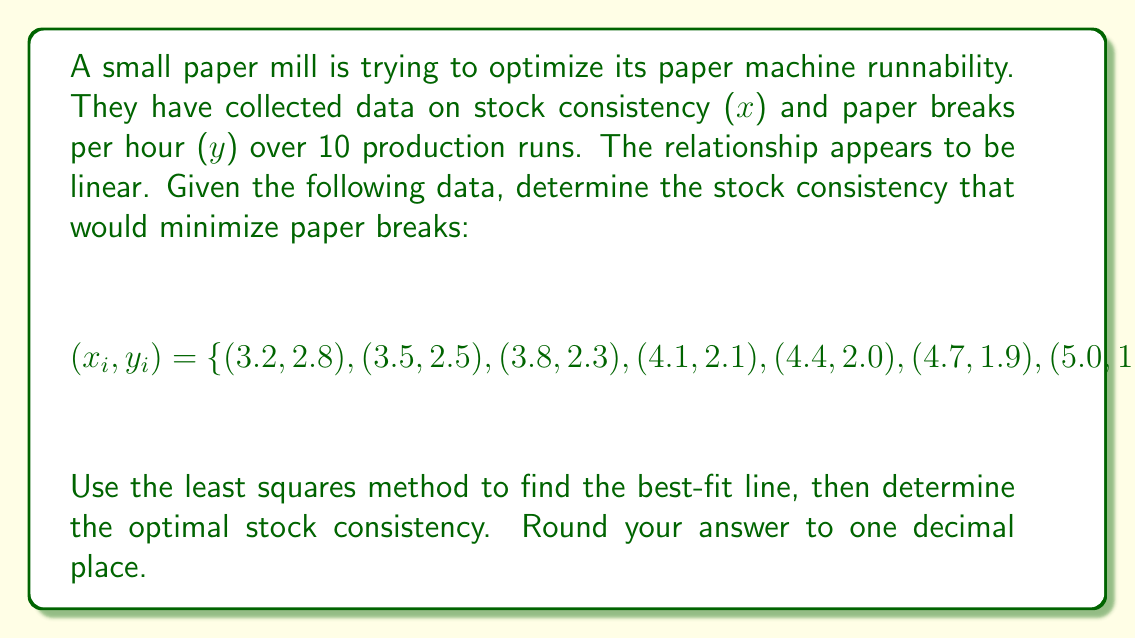Provide a solution to this math problem. To solve this problem, we'll follow these steps:

1) First, we need to find the equation of the best-fit line using the least squares method:
   $y = mx + b$

2) To find m and b, we use these formulas:
   $$m = \frac{n\sum xy - \sum x \sum y}{n\sum x^2 - (\sum x)^2}$$
   $$b = \frac{\sum y \sum x^2 - \sum x \sum xy}{n\sum x^2 - (\sum x)^2}$$

3) Let's calculate the necessary sums:
   $\sum x = 45.5$
   $\sum y = 22.2$
   $\sum xy = 99.31$
   $\sum x^2 = 216.35$
   $n = 10$

4) Now we can calculate m:
   $$m = \frac{10(99.31) - (45.5)(22.2)}{10(216.35) - (45.5)^2} = -0.348$$

5) And b:
   $$b = \frac{22.2(216.35) - 45.5(99.31)}{10(216.35) - (45.5)^2} = 3.913$$

6) So our best-fit line equation is:
   $y = -0.348x + 3.913$

7) To find the minimum number of breaks, we need to find the vertex of this parabola. The x-coordinate of the vertex will give us the optimal stock consistency.

8) The vertex occurs at the minimum point of the parabola, which is where the derivative of y with respect to x is zero. However, since our equation is already linear, the minimum will occur at the lowest or highest x-value in our dataset, depending on the slope.

9) Since our slope is negative, the minimum y-value (fewest breaks) will occur at the highest x-value in our dataset, which is 5.9.

Therefore, the optimal stock consistency is 5.9%.
Answer: 5.9% 